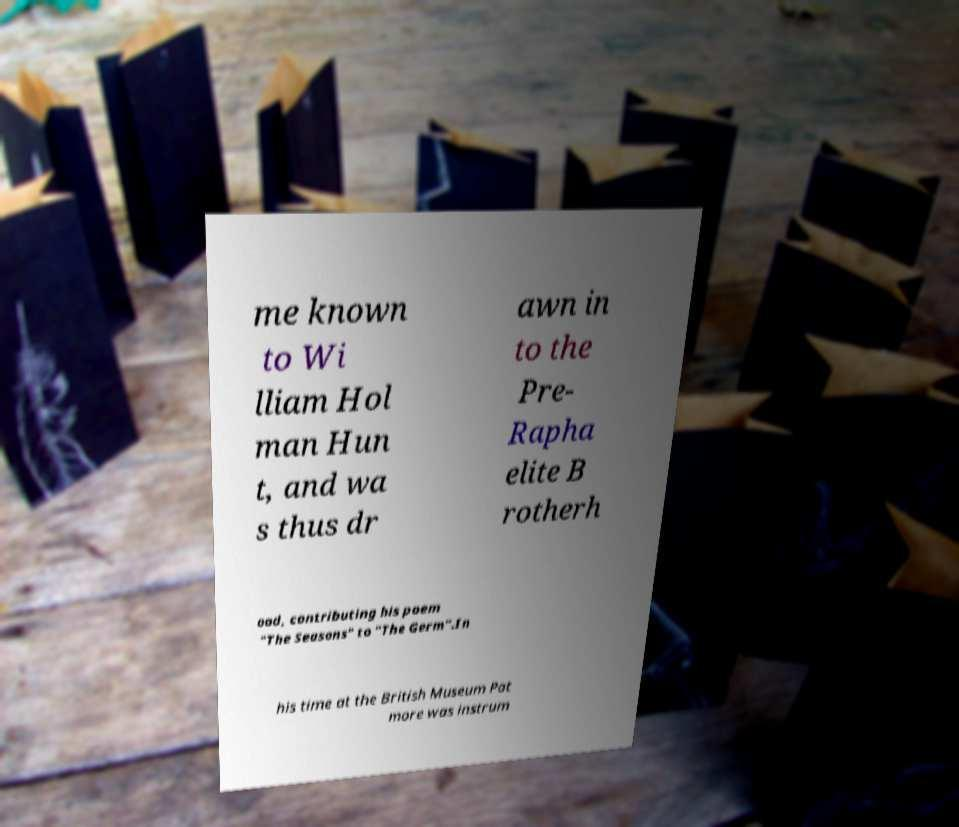For documentation purposes, I need the text within this image transcribed. Could you provide that? me known to Wi lliam Hol man Hun t, and wa s thus dr awn in to the Pre- Rapha elite B rotherh ood, contributing his poem "The Seasons" to "The Germ".In his time at the British Museum Pat more was instrum 